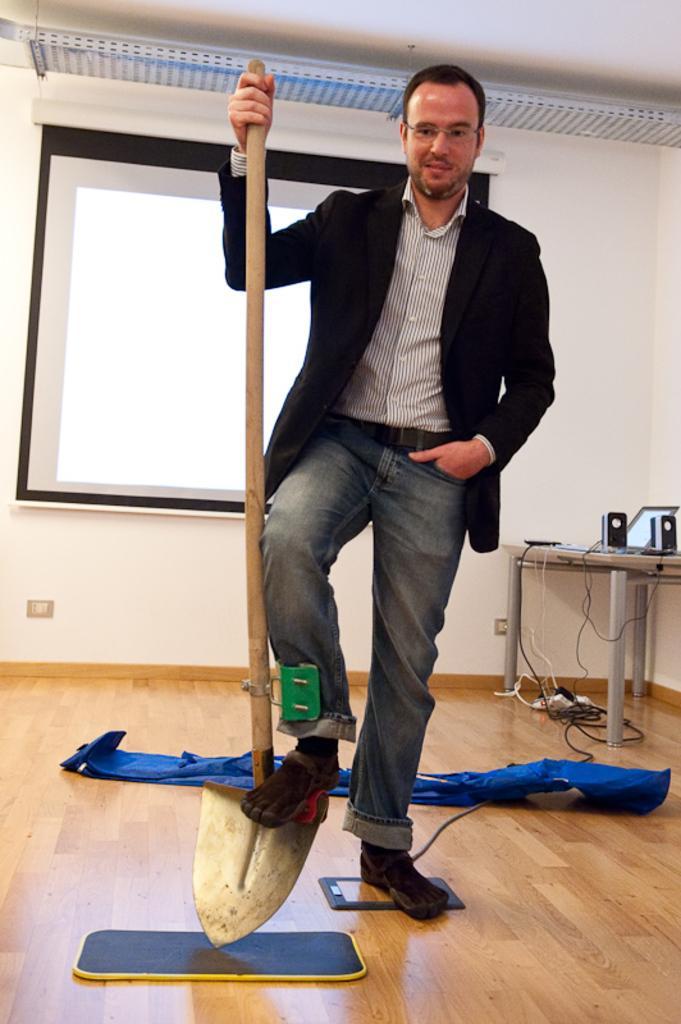Can you describe this image briefly? In this image, we can see a person standing and wearing clothes. This person is holding a shovel with his hand. There is a screen on the wall. There is a table on the right side of the image contains laptop and speakers. There is a cloth on the floor. 